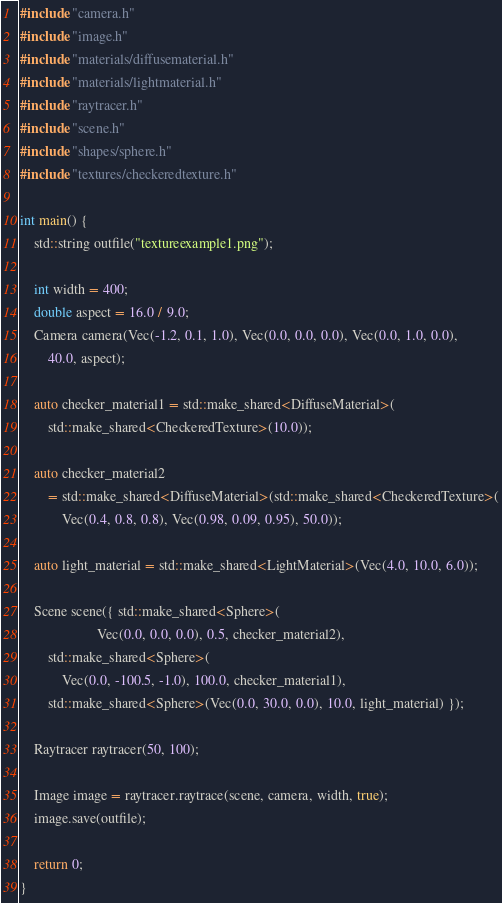Convert code to text. <code><loc_0><loc_0><loc_500><loc_500><_C++_>#include "camera.h"
#include "image.h"
#include "materials/diffusematerial.h"
#include "materials/lightmaterial.h"
#include "raytracer.h"
#include "scene.h"
#include "shapes/sphere.h"
#include "textures/checkeredtexture.h"

int main() {
    std::string outfile("textureexample1.png");

    int width = 400;
    double aspect = 16.0 / 9.0;
    Camera camera(Vec(-1.2, 0.1, 1.0), Vec(0.0, 0.0, 0.0), Vec(0.0, 1.0, 0.0),
        40.0, aspect);

    auto checker_material1 = std::make_shared<DiffuseMaterial>(
        std::make_shared<CheckeredTexture>(10.0));

    auto checker_material2
        = std::make_shared<DiffuseMaterial>(std::make_shared<CheckeredTexture>(
            Vec(0.4, 0.8, 0.8), Vec(0.98, 0.09, 0.95), 50.0));

    auto light_material = std::make_shared<LightMaterial>(Vec(4.0, 10.0, 6.0));

    Scene scene({ std::make_shared<Sphere>(
                      Vec(0.0, 0.0, 0.0), 0.5, checker_material2),
        std::make_shared<Sphere>(
            Vec(0.0, -100.5, -1.0), 100.0, checker_material1),
        std::make_shared<Sphere>(Vec(0.0, 30.0, 0.0), 10.0, light_material) });

    Raytracer raytracer(50, 100);

    Image image = raytracer.raytrace(scene, camera, width, true);
    image.save(outfile);

    return 0;
}
</code> 